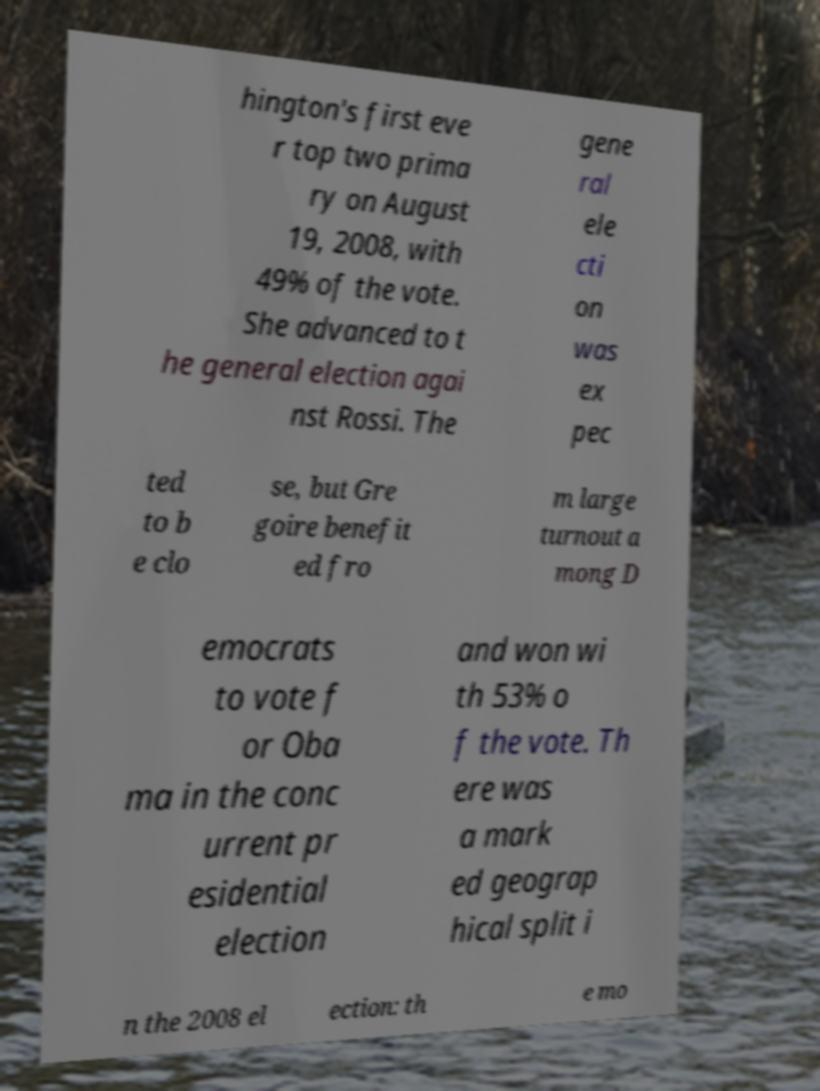Can you read and provide the text displayed in the image?This photo seems to have some interesting text. Can you extract and type it out for me? hington's first eve r top two prima ry on August 19, 2008, with 49% of the vote. She advanced to t he general election agai nst Rossi. The gene ral ele cti on was ex pec ted to b e clo se, but Gre goire benefit ed fro m large turnout a mong D emocrats to vote f or Oba ma in the conc urrent pr esidential election and won wi th 53% o f the vote. Th ere was a mark ed geograp hical split i n the 2008 el ection: th e mo 